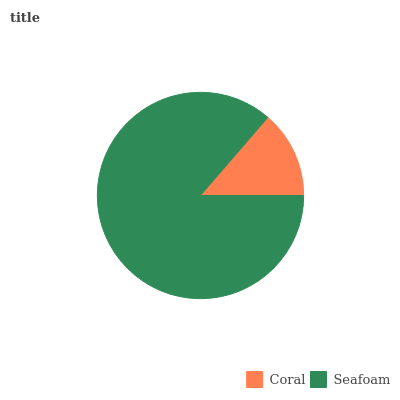Is Coral the minimum?
Answer yes or no. Yes. Is Seafoam the maximum?
Answer yes or no. Yes. Is Seafoam the minimum?
Answer yes or no. No. Is Seafoam greater than Coral?
Answer yes or no. Yes. Is Coral less than Seafoam?
Answer yes or no. Yes. Is Coral greater than Seafoam?
Answer yes or no. No. Is Seafoam less than Coral?
Answer yes or no. No. Is Seafoam the high median?
Answer yes or no. Yes. Is Coral the low median?
Answer yes or no. Yes. Is Coral the high median?
Answer yes or no. No. Is Seafoam the low median?
Answer yes or no. No. 